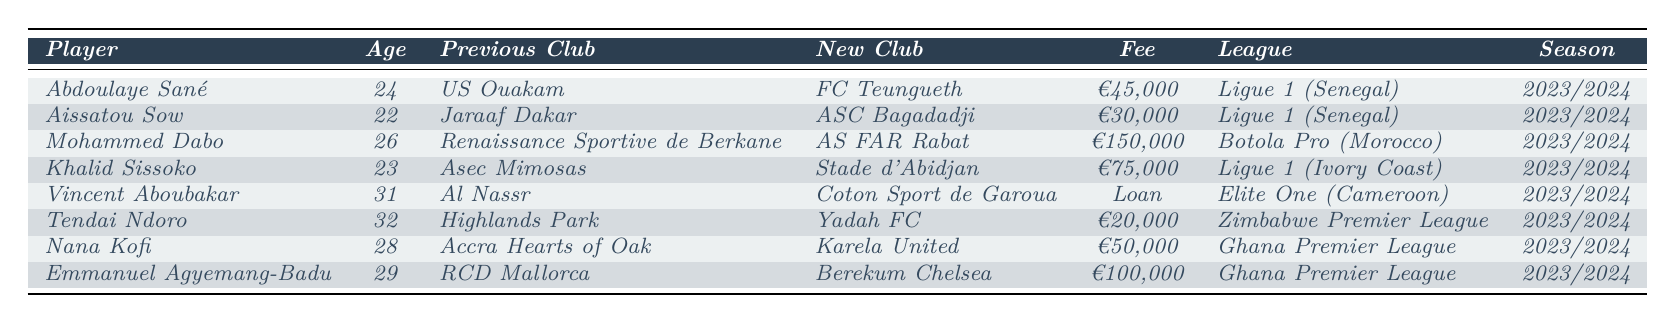What is the most expensive transfer in the table? The most expensive transfer is identified by scanning through the transfer fees listed for each player. Mohammed Dabo from Renaissance Sportive de Berkane to AS FAR Rabat has a transfer fee of €150,000, which is higher than all other transfers.
Answer: €150,000 How many players are transferred from or to clubs in Ligue 1 (Senegal)? By reviewing the table, there are 2 players listed as transferring to or from clubs in Ligue 1 (Senegal): Abdoulaye Sané and Aissatou Sow.
Answer: 2 Which player is the youngest in the table? The ages of all players are listed. Aissatou Sow is 22 years old, which is younger than any other player listed.
Answer: Aissatou Sow Is there any player who transferred for a loan fee? The table indicates that Vincent Aboubakar's transfer is listed as a loan. Therefore, the answer is yes.
Answer: Yes What is the total transfer fee of all players listed? To find the total transfer fee, I sum the fees of all players, treating the loan fee as €0: €45,000 + €30,000 + €150,000 + €75,000 + €0 + €20,000 + €50,000 + €100,000 = €370,000.
Answer: €370,000 Which league has the highest-value transfer? By comparing the highest fees associated with players in each league, Mohammed Dabo's transfer in Botola Pro (Morocco) for €150,000 is the highest.
Answer: Botola Pro (Morocco) How many players are moving to clubs in the Ghana Premier League? A review of the table shows that there are two players moving to clubs in the Ghana Premier League: Nana Kofi and Emmanuel Agyemang-Badu.
Answer: 2 What is the average age of players who moved to the Senegalese Ligue 1? The ages of players moving in Ligue 1 (Senegal) are 24 (Abdoulaye Sané) and 22 (Aissatou Sow). The average age is calculated as (24 + 22)/2 = 23.
Answer: 23 Which club did Khalid Sissoko come from? According to the table, Khalid Sissoko transferred from Asec Mimosas.
Answer: Asec Mimosas How many transfers involved a fee less than €50,000? Players with fees less than €50,000 are Tendai Ndoro (€20,000), Aissatou Sow (€30,000), and Nana Kofi (€50,000 is not less). Therefore, there are two players that moved for fees below €50,000.
Answer: 2 Which player switched clubs from the Ivory Coast? Looking at the table, Khalid Sissoko is the player who transferred from Asec Mimosas (Ivory Coast) to Stade d'Abidjan.
Answer: Khalid Sissoko 